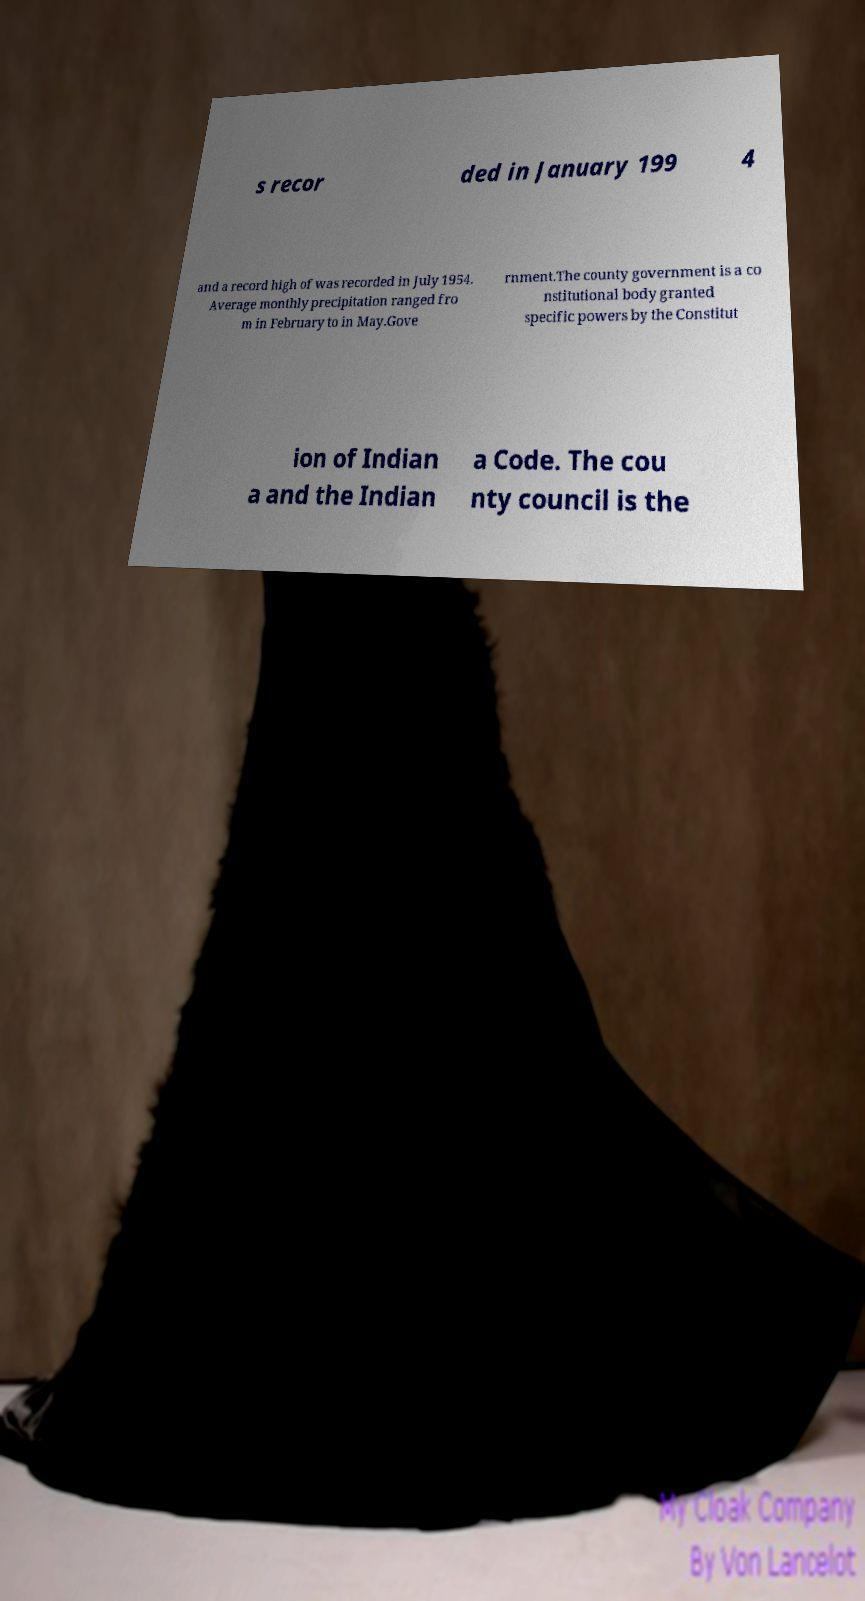Could you assist in decoding the text presented in this image and type it out clearly? s recor ded in January 199 4 and a record high of was recorded in July 1954. Average monthly precipitation ranged fro m in February to in May.Gove rnment.The county government is a co nstitutional body granted specific powers by the Constitut ion of Indian a and the Indian a Code. The cou nty council is the 